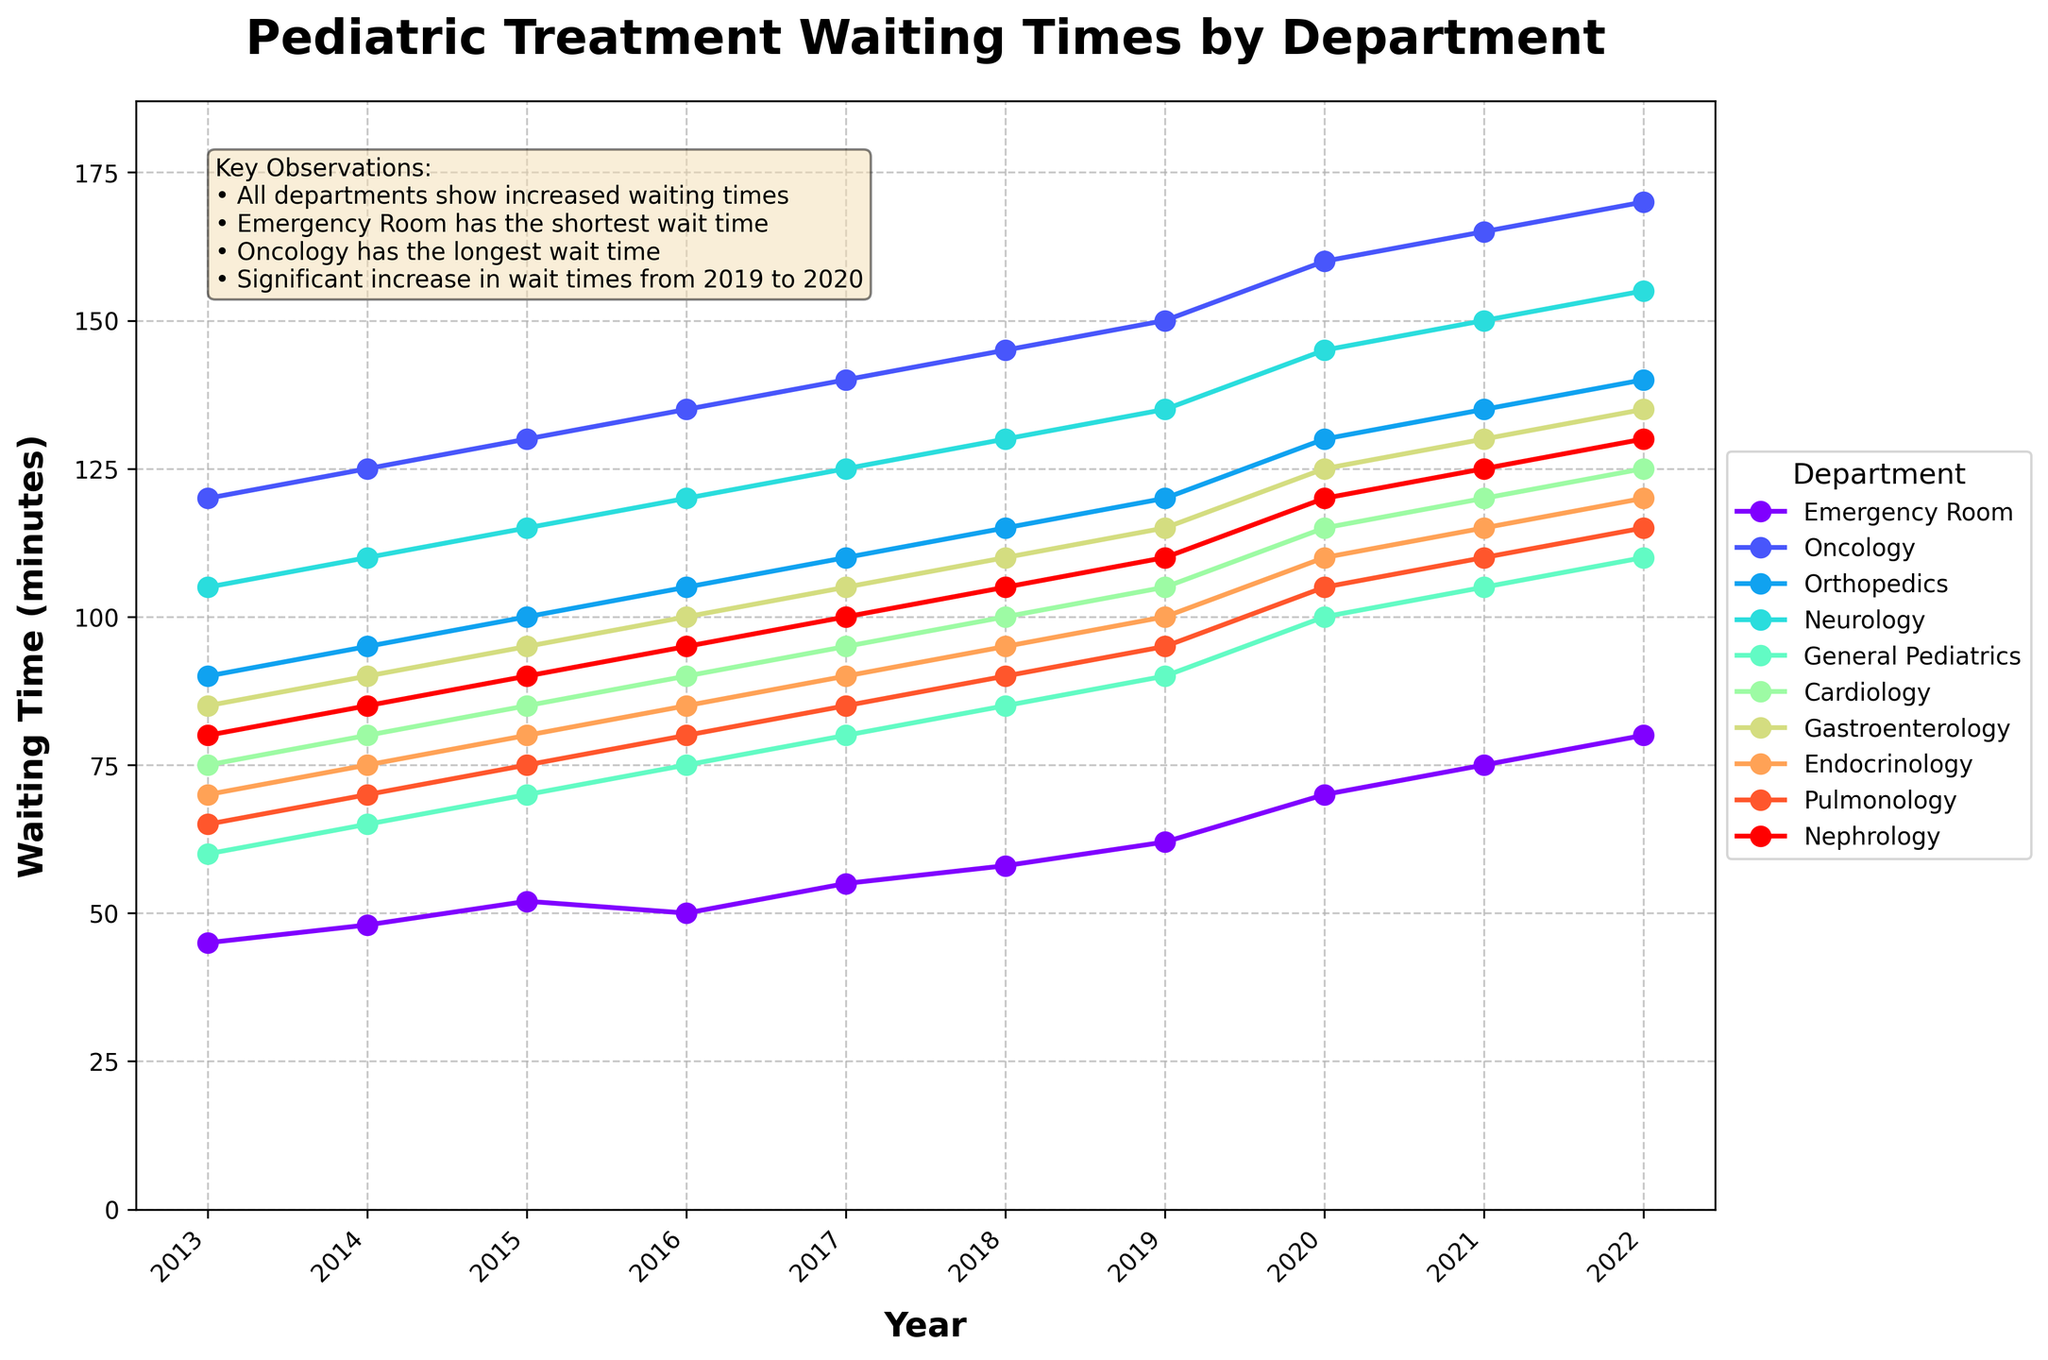Which department has the shortest waiting time in 2022? Look for the department with the lowest value on the 2022 axis. The Emergency Room has the lowest value of 80 minutes.
Answer: Emergency Room Which department has the longest waiting time in 2022? Look for the department with the highest value on the 2022 axis. The Oncology department has the highest value of 170 minutes.
Answer: Oncology What is the average waiting time for Cardiology and Pulmonology in 2022? Find the 2022 values for both Cardiology and Pulmonology, which are 125 and 115 minutes respectively. The average is (125 + 115) / 2.
Answer: 120 How much did waiting times increase for Endocrinology from 2019 to 2020? Look at the values for Endocrinology in 2019 and 2020, which are 100 and 110 minutes respectively. The increase is 110 - 100.
Answer: 10 minutes Which department had the largest increase in waiting time from 2019 to 2020? Check the difference between the 2019 and 2020 values for each department. The Emergency Room increased the most, from 62 to 70 minutes, an increase of 8 minutes.
Answer: Emergency Room Compare the waiting times in 2013 between General Pediatrics and Orthopedics. Which one is higher? Look at the 2013 values for both General Pediatrics and Orthopedics. General Pediatrics has 60 minutes and Orthopedics has 90 minutes. Orthopedics is higher.
Answer: Orthopedics In which year did Cardiology and Nephrology have the same waiting time? Check the chart for when the Cardiology and Nephrology lines intersect. In 2015, both have a waiting time of 85 minutes.
Answer: 2015 What is the difference between the waiting times for Oncology and Pulmonology in 2022? Find the 2022 values for both Oncology and Pulmonology, which are 170 and 115 minutes respectively. The difference is 170 - 115.
Answer: 55 minutes Did the waiting time for Neurology ever decrease over the decade? Look at the trend line for Neurology from 2013 to 2022. The line constantly increases, so it never decreases.
Answer: No Which departments have waiting times over 100 minutes in 2018? Look for departments with values above 100 minutes in 2018. These departments are Oncology, Orthopedics, Neurology, General Pediatrics, Cardiology, and Gastroenterology.
Answer: Oncology, Orthopedics, Neurology, General Pediatrics, Cardiology, Gastroenterology 